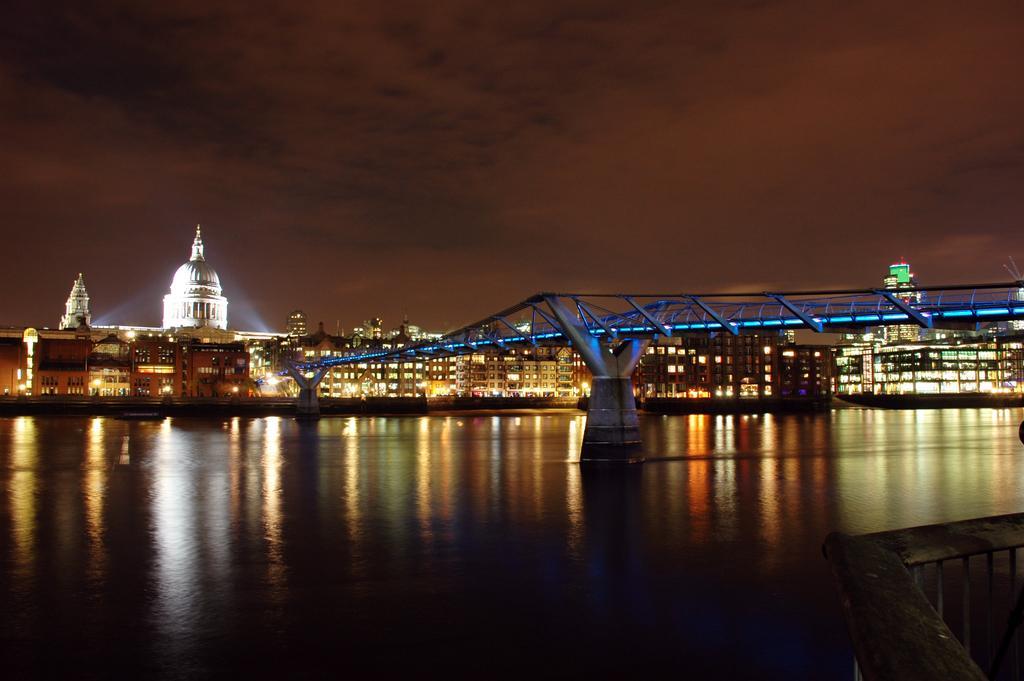Could you give a brief overview of what you see in this image? In this image there are few buildings, a bridge over the water, a fence and some clouds in the sky. 